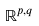Convert formula to latex. <formula><loc_0><loc_0><loc_500><loc_500>\mathbb { R } ^ { p , q }</formula> 